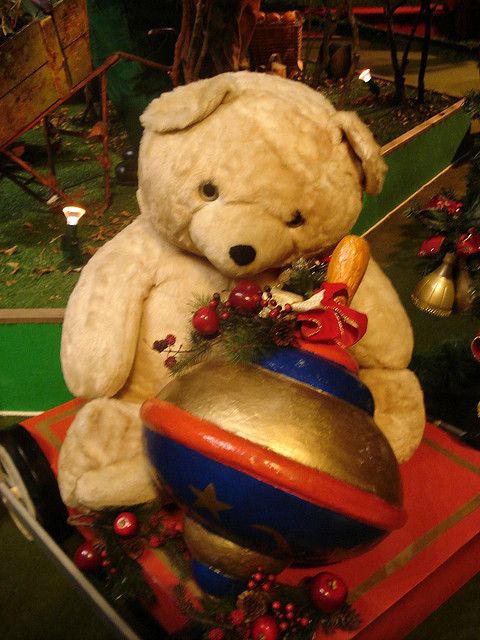How many people are walking under the umbrella? There are no people visible in this image; instead, we see a teddy bear seated next to a large ornament, perhaps suggesting a festive holiday setting. 